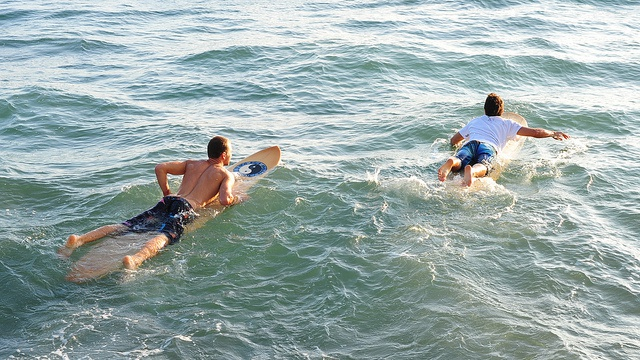Describe the objects in this image and their specific colors. I can see people in lightblue, brown, black, gray, and darkgray tones, surfboard in lightblue, darkgray, gray, and tan tones, people in lightblue, lavender, lightgray, and black tones, and surfboard in lightblue, ivory, and tan tones in this image. 